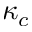Convert formula to latex. <formula><loc_0><loc_0><loc_500><loc_500>\kappa _ { c }</formula> 